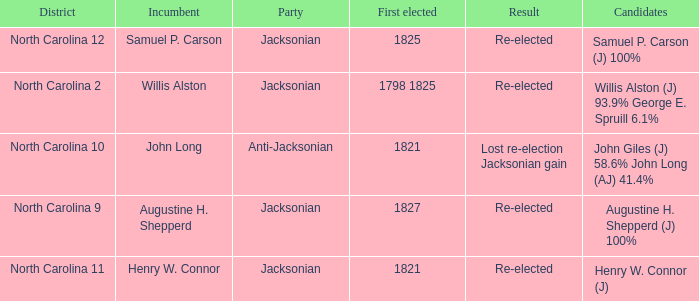Name the district for anti-jacksonian North Carolina 10. 